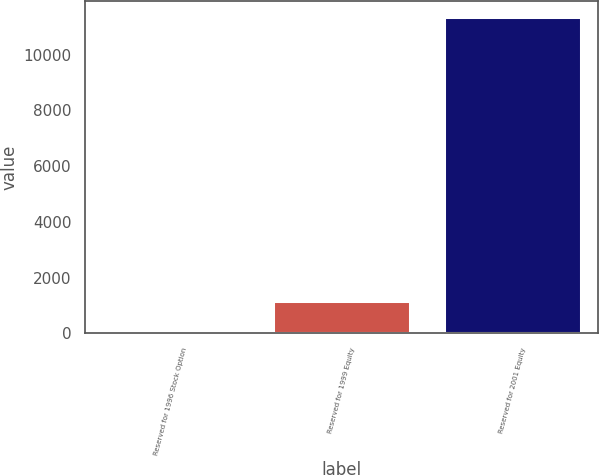Convert chart to OTSL. <chart><loc_0><loc_0><loc_500><loc_500><bar_chart><fcel>Reserved for 1996 Stock Option<fcel>Reserved for 1999 Equity<fcel>Reserved for 2001 Equity<nl><fcel>20<fcel>1152.4<fcel>11344<nl></chart> 